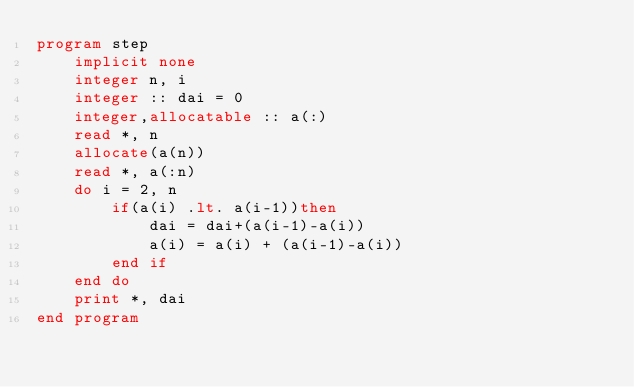Convert code to text. <code><loc_0><loc_0><loc_500><loc_500><_FORTRAN_>program step
    implicit none
    integer n, i
    integer :: dai = 0
    integer,allocatable :: a(:)
    read *, n
    allocate(a(n))
    read *, a(:n)
    do i = 2, n
        if(a(i) .lt. a(i-1))then
            dai = dai+(a(i-1)-a(i))
            a(i) = a(i) + (a(i-1)-a(i))
        end if
    end do
    print *, dai
end program</code> 